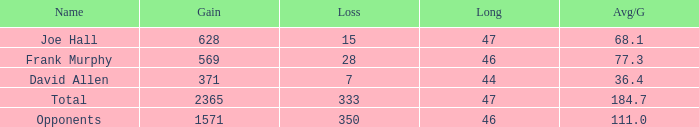Calculate the loss when gain is under 1571, long is under 47, and avg/g is 36.4. 1.0. 